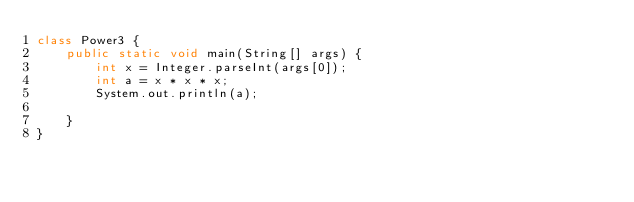Convert code to text. <code><loc_0><loc_0><loc_500><loc_500><_Java_>class Power3 {
	public static void main(String[] args) {
		int x = Integer.parseInt(args[0]);
		int a = x * x * x;
		System.out.println(a);
	
	}
}</code> 